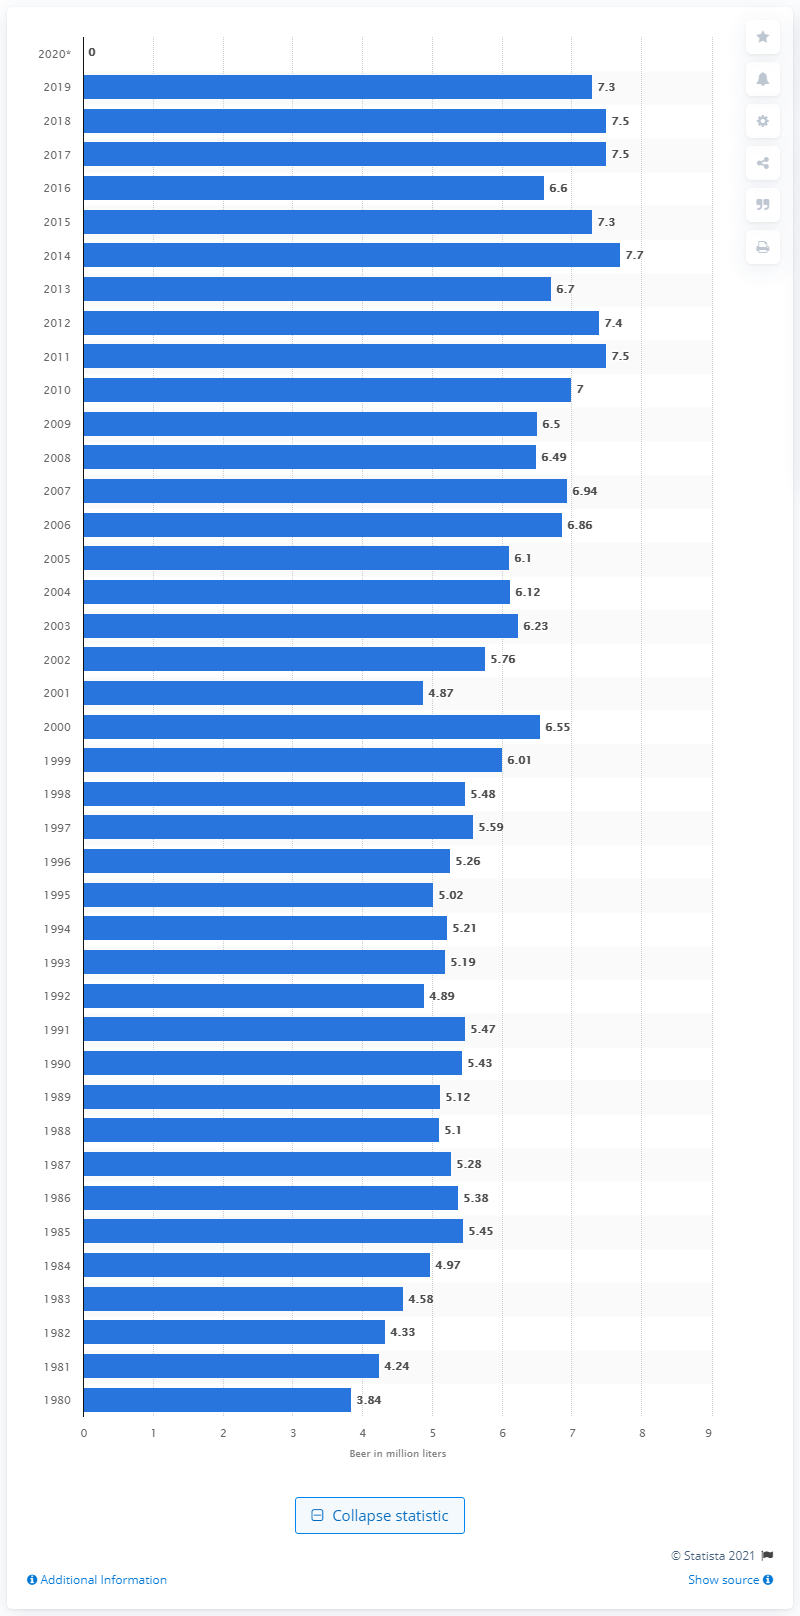Highlight a few significant elements in this photo. The Oktoberfest in Munich in 2019 saw the pouring of 7,300 liters of beer. 